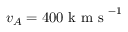<formula> <loc_0><loc_0><loc_500><loc_500>v _ { A } = 4 0 0 k m s ^ { - 1 }</formula> 